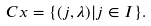<formula> <loc_0><loc_0><loc_500><loc_500>C x = \{ ( j , \lambda ) | j \in I \} .</formula> 